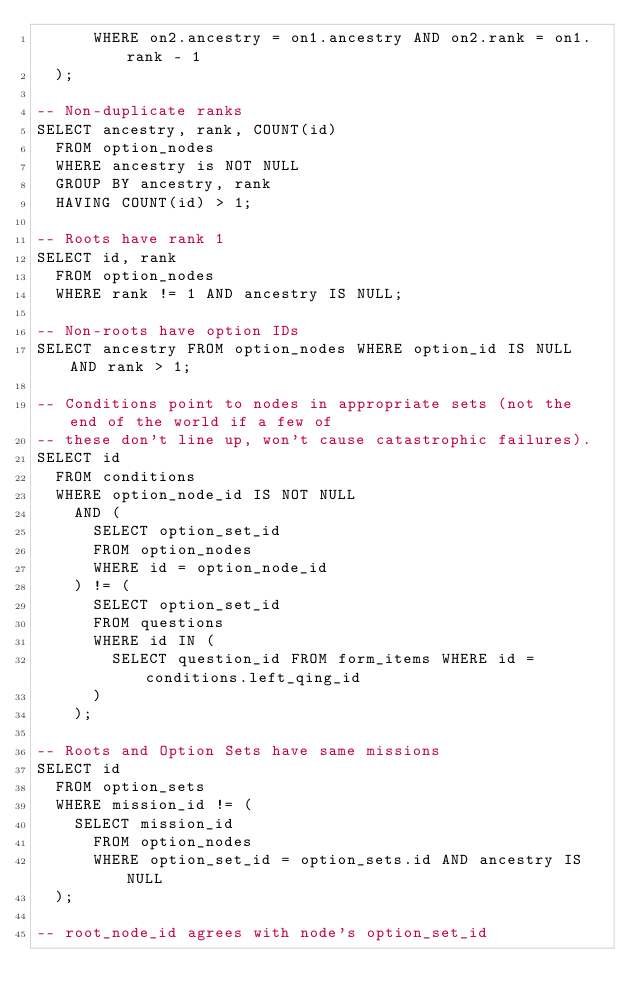Convert code to text. <code><loc_0><loc_0><loc_500><loc_500><_SQL_>      WHERE on2.ancestry = on1.ancestry AND on2.rank = on1.rank - 1
  );

-- Non-duplicate ranks
SELECT ancestry, rank, COUNT(id)
  FROM option_nodes
  WHERE ancestry is NOT NULL
  GROUP BY ancestry, rank
  HAVING COUNT(id) > 1;

-- Roots have rank 1
SELECT id, rank
  FROM option_nodes
  WHERE rank != 1 AND ancestry IS NULL;

-- Non-roots have option IDs
SELECT ancestry FROM option_nodes WHERE option_id IS NULL AND rank > 1;

-- Conditions point to nodes in appropriate sets (not the end of the world if a few of
-- these don't line up, won't cause catastrophic failures).
SELECT id
  FROM conditions
  WHERE option_node_id IS NOT NULL
    AND (
      SELECT option_set_id
      FROM option_nodes
      WHERE id = option_node_id
    ) != (
      SELECT option_set_id
      FROM questions
      WHERE id IN (
        SELECT question_id FROM form_items WHERE id = conditions.left_qing_id
      )
    );

-- Roots and Option Sets have same missions
SELECT id
  FROM option_sets
  WHERE mission_id != (
    SELECT mission_id
      FROM option_nodes
      WHERE option_set_id = option_sets.id AND ancestry IS NULL
  );

-- root_node_id agrees with node's option_set_id</code> 